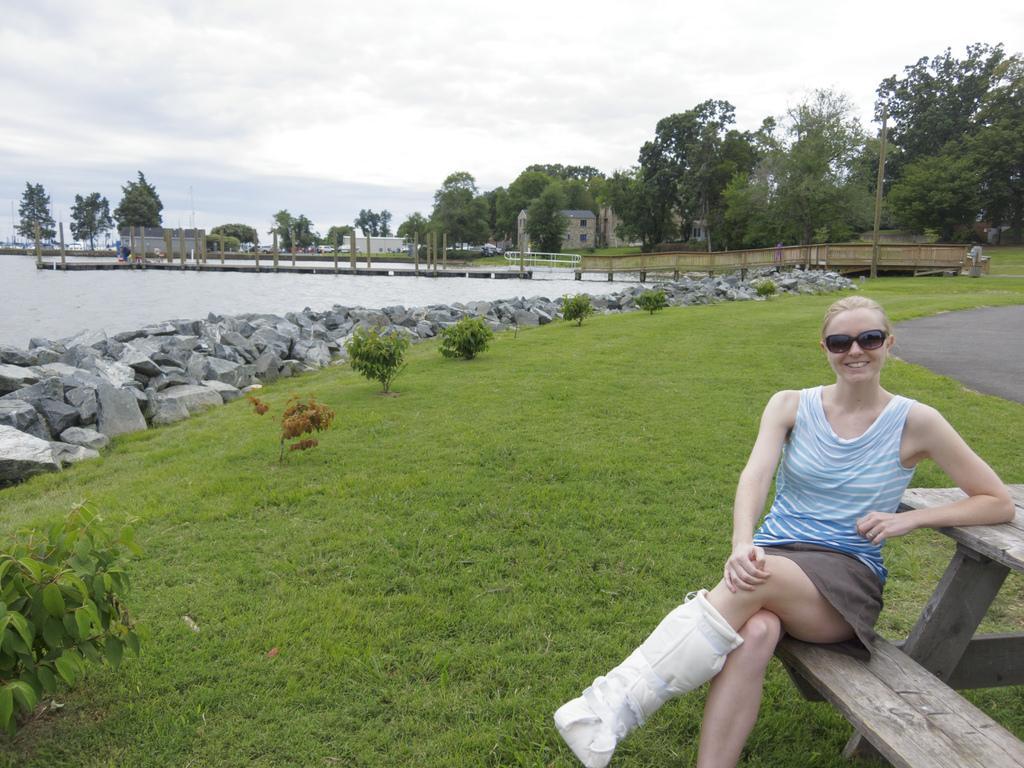In one or two sentences, can you explain what this image depicts? In this picture there is a woman sitting and she is smiling. At the back there is a bridge and there are buildings and trees. On the left side of the image there is water and there are stones and plants. On the right side of the image there is a road. At the top there is sky and there are clouds. At the bottom there is grass. 